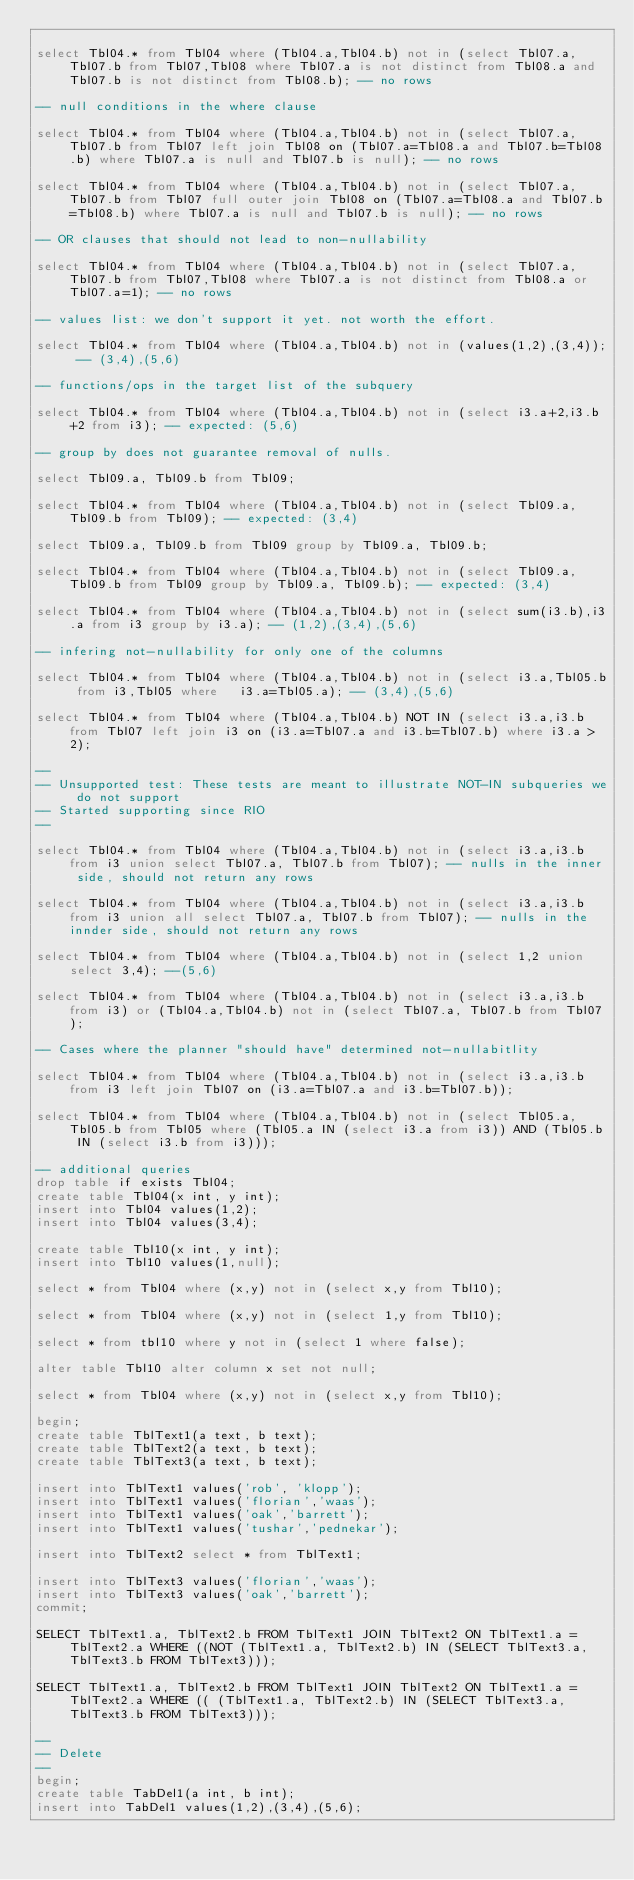<code> <loc_0><loc_0><loc_500><loc_500><_SQL_>
select Tbl04.* from Tbl04 where (Tbl04.a,Tbl04.b) not in (select Tbl07.a,Tbl07.b from Tbl07,Tbl08 where Tbl07.a is not distinct from Tbl08.a and Tbl07.b is not distinct from Tbl08.b); -- no rows

-- null conditions in the where clause

select Tbl04.* from Tbl04 where (Tbl04.a,Tbl04.b) not in (select Tbl07.a,Tbl07.b from Tbl07 left join Tbl08 on (Tbl07.a=Tbl08.a and Tbl07.b=Tbl08.b) where Tbl07.a is null and Tbl07.b is null); -- no rows

select Tbl04.* from Tbl04 where (Tbl04.a,Tbl04.b) not in (select Tbl07.a,Tbl07.b from Tbl07 full outer join Tbl08 on (Tbl07.a=Tbl08.a and Tbl07.b=Tbl08.b) where Tbl07.a is null and Tbl07.b is null); -- no rows

-- OR clauses that should not lead to non-nullability

select Tbl04.* from Tbl04 where (Tbl04.a,Tbl04.b) not in (select Tbl07.a,Tbl07.b from Tbl07,Tbl08 where Tbl07.a is not distinct from Tbl08.a or Tbl07.a=1); -- no rows

-- values list: we don't support it yet. not worth the effort.

select Tbl04.* from Tbl04 where (Tbl04.a,Tbl04.b) not in (values(1,2),(3,4)); -- (3,4),(5,6)

-- functions/ops in the target list of the subquery

select Tbl04.* from Tbl04 where (Tbl04.a,Tbl04.b) not in (select i3.a+2,i3.b+2 from i3); -- expected: (5,6)

-- group by does not guarantee removal of nulls. 

select Tbl09.a, Tbl09.b from Tbl09;

select Tbl04.* from Tbl04 where (Tbl04.a,Tbl04.b) not in (select Tbl09.a,Tbl09.b from Tbl09); -- expected: (3,4)

select Tbl09.a, Tbl09.b from Tbl09 group by Tbl09.a, Tbl09.b;

select Tbl04.* from Tbl04 where (Tbl04.a,Tbl04.b) not in (select Tbl09.a, Tbl09.b from Tbl09 group by Tbl09.a, Tbl09.b); -- expected: (3,4)

select Tbl04.* from Tbl04 where (Tbl04.a,Tbl04.b) not in (select sum(i3.b),i3.a from i3 group by i3.a); -- (1,2),(3,4),(5,6)

-- infering not-nullability for only one of the columns

select Tbl04.* from Tbl04 where (Tbl04.a,Tbl04.b) not in (select i3.a,Tbl05.b from i3,Tbl05 where	i3.a=Tbl05.a); -- (3,4),(5,6)

select Tbl04.* from Tbl04 where (Tbl04.a,Tbl04.b) NOT IN (select i3.a,i3.b from Tbl07 left join i3 on (i3.a=Tbl07.a and i3.b=Tbl07.b) where i3.a > 2);

--
-- Unsupported test: These tests are meant to illustrate NOT-IN subqueries we do not support
-- Started supporting since RIO
--

select Tbl04.* from Tbl04 where (Tbl04.a,Tbl04.b) not in (select i3.a,i3.b from i3 union select Tbl07.a, Tbl07.b from Tbl07); -- nulls in the inner side, should not return any rows

select Tbl04.* from Tbl04 where (Tbl04.a,Tbl04.b) not in (select i3.a,i3.b from i3 union all select Tbl07.a, Tbl07.b from Tbl07); -- nulls in the innder side, should not return any rows

select Tbl04.* from Tbl04 where (Tbl04.a,Tbl04.b) not in (select 1,2 union select 3,4); --(5,6)

select Tbl04.* from Tbl04 where (Tbl04.a,Tbl04.b) not in (select i3.a,i3.b from i3) or (Tbl04.a,Tbl04.b) not in (select Tbl07.a, Tbl07.b from Tbl07);

-- Cases where the planner "should have" determined not-nullabitlity

select Tbl04.* from Tbl04 where (Tbl04.a,Tbl04.b) not in (select i3.a,i3.b from i3 left join Tbl07 on (i3.a=Tbl07.a and i3.b=Tbl07.b));

select Tbl04.* from Tbl04 where (Tbl04.a,Tbl04.b) not in (select Tbl05.a,Tbl05.b from Tbl05 where (Tbl05.a IN (select i3.a from i3)) AND (Tbl05.b IN (select i3.b from i3)));

-- additional queries
drop table if exists Tbl04;
create table Tbl04(x int, y int);
insert into Tbl04 values(1,2);
insert into Tbl04 values(3,4);

create table Tbl10(x int, y int);
insert into Tbl10 values(1,null);

select * from Tbl04 where (x,y) not in (select x,y from Tbl10);

select * from Tbl04 where (x,y) not in (select 1,y from Tbl10);

select * from tbl10 where y not in (select 1 where false);

alter table Tbl10 alter column x set not null;

select * from Tbl04 where (x,y) not in (select x,y from Tbl10);

begin;
create table TblText1(a text, b text);
create table TblText2(a text, b text);
create table TblText3(a text, b text);

insert into TblText1 values('rob', 'klopp');
insert into TblText1 values('florian','waas');
insert into TblText1 values('oak','barrett');
insert into TblText1 values('tushar','pednekar');

insert into TblText2 select * from TblText1;

insert into TblText3 values('florian','waas');
insert into TblText3 values('oak','barrett');
commit;

SELECT TblText1.a, TblText2.b FROM TblText1 JOIN TblText2 ON TblText1.a = TblText2.a WHERE ((NOT (TblText1.a, TblText2.b) IN (SELECT TblText3.a, TblText3.b FROM TblText3)));

SELECT TblText1.a, TblText2.b FROM TblText1 JOIN TblText2 ON TblText1.a = TblText2.a WHERE (( (TblText1.a, TblText2.b) IN (SELECT TblText3.a, TblText3.b FROM TblText3)));

--
-- Delete
--
begin;
create table TabDel1(a int, b int);
insert into TabDel1 values(1,2),(3,4),(5,6);
</code> 